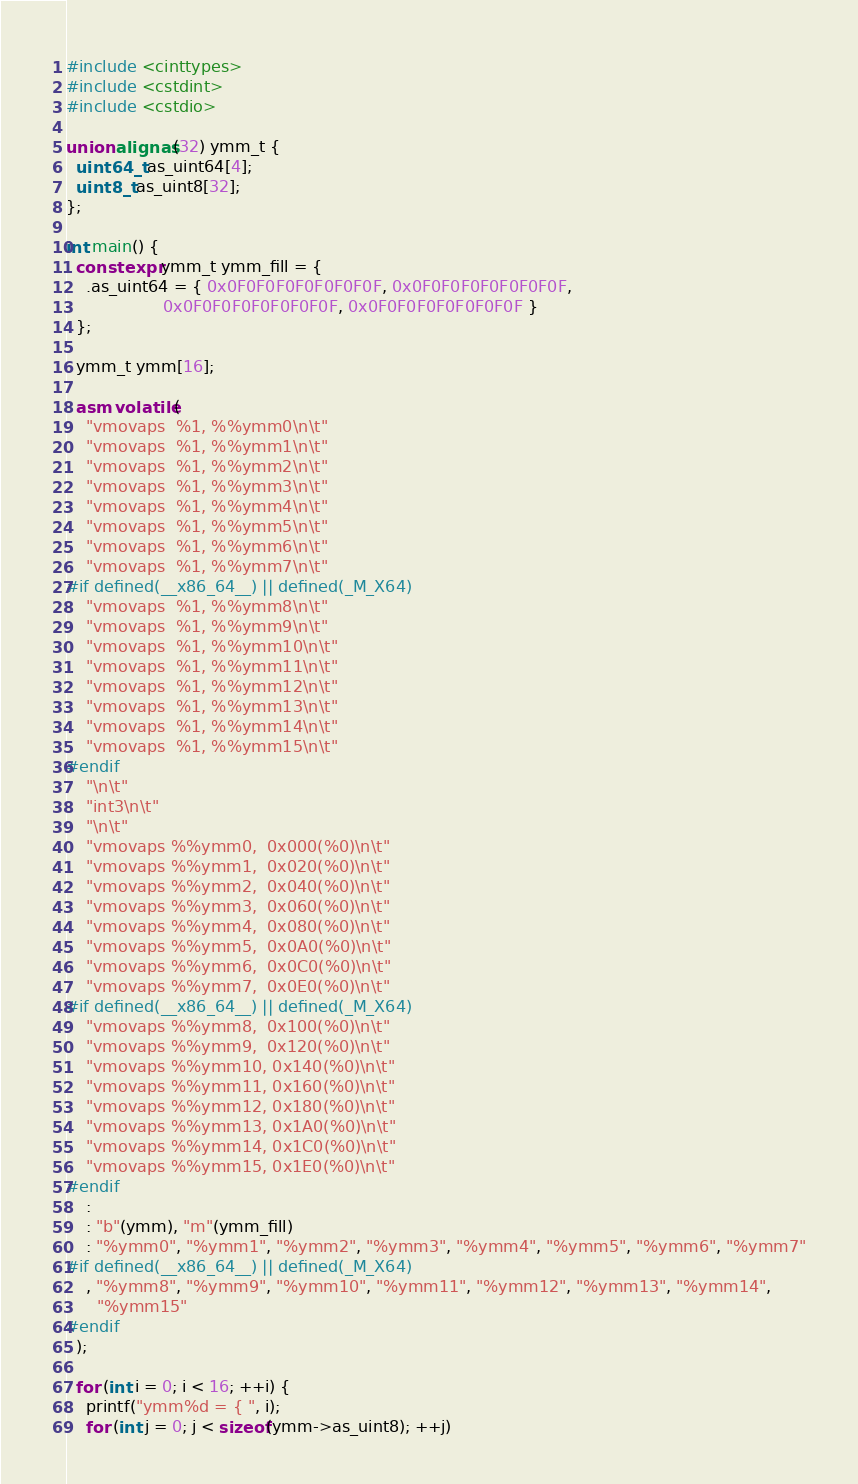<code> <loc_0><loc_0><loc_500><loc_500><_C++_>#include <cinttypes>
#include <cstdint>
#include <cstdio>

union alignas(32) ymm_t {
  uint64_t as_uint64[4];
  uint8_t as_uint8[32];
};

int main() {
  constexpr ymm_t ymm_fill = {
    .as_uint64 = { 0x0F0F0F0F0F0F0F0F, 0x0F0F0F0F0F0F0F0F,
                   0x0F0F0F0F0F0F0F0F, 0x0F0F0F0F0F0F0F0F }
  };

  ymm_t ymm[16];

  asm volatile(
    "vmovaps  %1, %%ymm0\n\t"
    "vmovaps  %1, %%ymm1\n\t"
    "vmovaps  %1, %%ymm2\n\t"
    "vmovaps  %1, %%ymm3\n\t"
    "vmovaps  %1, %%ymm4\n\t"
    "vmovaps  %1, %%ymm5\n\t"
    "vmovaps  %1, %%ymm6\n\t"
    "vmovaps  %1, %%ymm7\n\t"
#if defined(__x86_64__) || defined(_M_X64)
    "vmovaps  %1, %%ymm8\n\t"
    "vmovaps  %1, %%ymm9\n\t"
    "vmovaps  %1, %%ymm10\n\t"
    "vmovaps  %1, %%ymm11\n\t"
    "vmovaps  %1, %%ymm12\n\t"
    "vmovaps  %1, %%ymm13\n\t"
    "vmovaps  %1, %%ymm14\n\t"
    "vmovaps  %1, %%ymm15\n\t"
#endif
    "\n\t"
    "int3\n\t"
    "\n\t"
    "vmovaps %%ymm0,  0x000(%0)\n\t"
    "vmovaps %%ymm1,  0x020(%0)\n\t"
    "vmovaps %%ymm2,  0x040(%0)\n\t"
    "vmovaps %%ymm3,  0x060(%0)\n\t"
    "vmovaps %%ymm4,  0x080(%0)\n\t"
    "vmovaps %%ymm5,  0x0A0(%0)\n\t"
    "vmovaps %%ymm6,  0x0C0(%0)\n\t"
    "vmovaps %%ymm7,  0x0E0(%0)\n\t"
#if defined(__x86_64__) || defined(_M_X64)
    "vmovaps %%ymm8,  0x100(%0)\n\t"
    "vmovaps %%ymm9,  0x120(%0)\n\t"
    "vmovaps %%ymm10, 0x140(%0)\n\t"
    "vmovaps %%ymm11, 0x160(%0)\n\t"
    "vmovaps %%ymm12, 0x180(%0)\n\t"
    "vmovaps %%ymm13, 0x1A0(%0)\n\t"
    "vmovaps %%ymm14, 0x1C0(%0)\n\t"
    "vmovaps %%ymm15, 0x1E0(%0)\n\t"
#endif
    :
    : "b"(ymm), "m"(ymm_fill)
    : "%ymm0", "%ymm1", "%ymm2", "%ymm3", "%ymm4", "%ymm5", "%ymm6", "%ymm7"
#if defined(__x86_64__) || defined(_M_X64)
    , "%ymm8", "%ymm9", "%ymm10", "%ymm11", "%ymm12", "%ymm13", "%ymm14",
      "%ymm15"
#endif
  );

  for (int i = 0; i < 16; ++i) {
    printf("ymm%d = { ", i);
    for (int j = 0; j < sizeof(ymm->as_uint8); ++j)</code> 